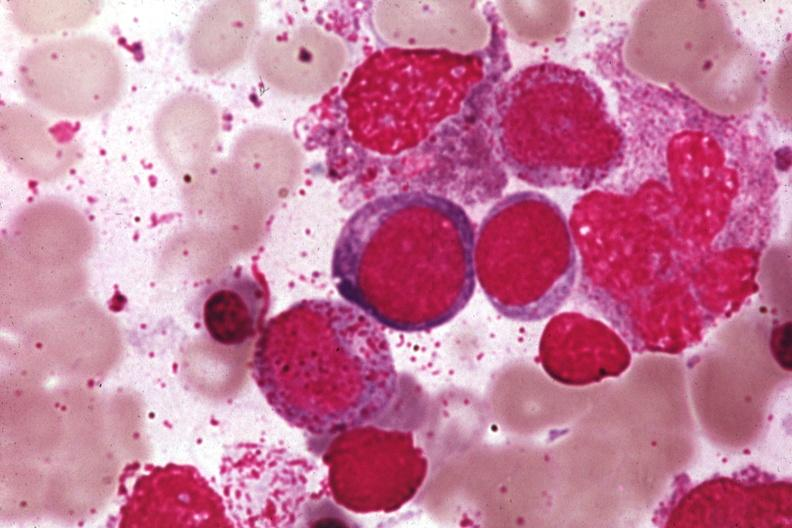s plasma cell present?
Answer the question using a single word or phrase. No 